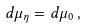Convert formula to latex. <formula><loc_0><loc_0><loc_500><loc_500>d \mu _ { \eta } = d \mu _ { 0 } \, ,</formula> 